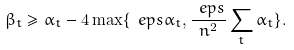Convert formula to latex. <formula><loc_0><loc_0><loc_500><loc_500>\beta _ { t } \geq \alpha _ { t } - 4 \max \{ \ e p s \alpha _ { t } , \frac { \ e p s } { n ^ { 2 } } \sum _ { t } \alpha _ { t } \} .</formula> 